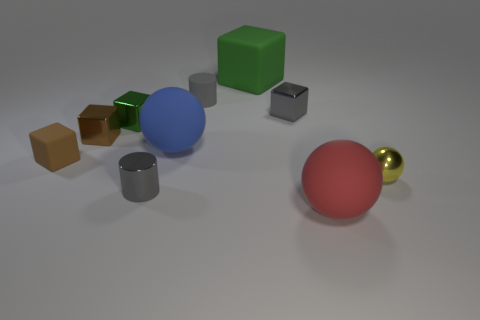Subtract all cyan cylinders. How many green cubes are left? 2 Subtract all large balls. How many balls are left? 1 Subtract 2 blocks. How many blocks are left? 3 Subtract all green cubes. How many cubes are left? 3 Subtract all cyan blocks. Subtract all green cylinders. How many blocks are left? 5 Subtract all spheres. How many objects are left? 7 Add 5 tiny metal blocks. How many tiny metal blocks exist? 8 Subtract 0 blue cubes. How many objects are left? 10 Subtract all brown things. Subtract all small matte blocks. How many objects are left? 7 Add 2 gray shiny cylinders. How many gray shiny cylinders are left? 3 